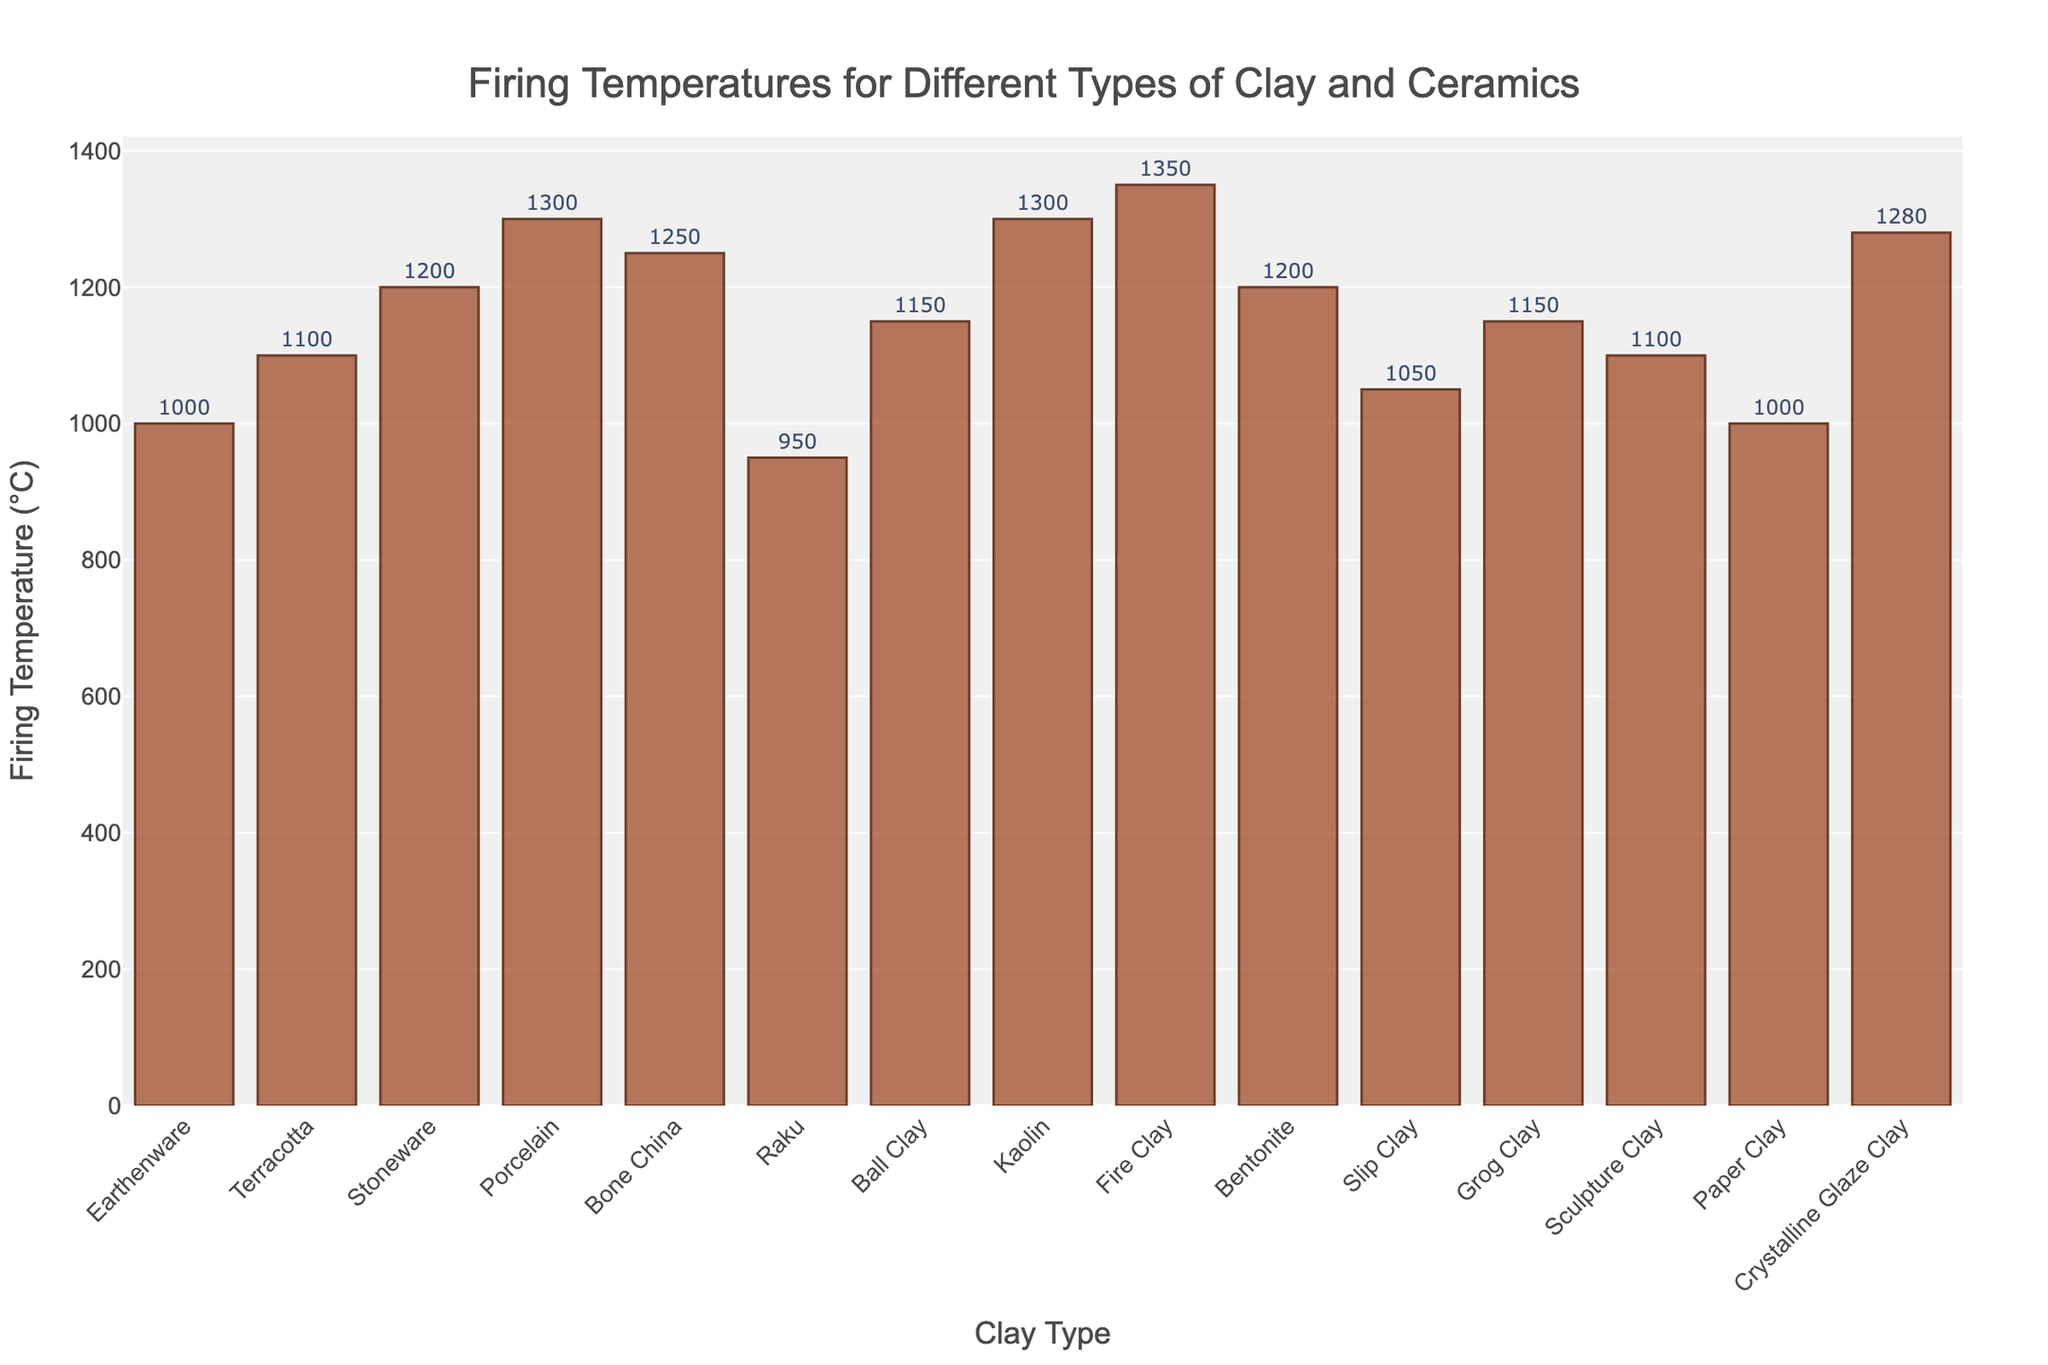Which clay type has the highest firing temperature? The highest bar in the bar chart represents the clay type with the highest firing temperature. Looking at the bars, "Fire Clay" stands out as the highest.
Answer: Fire Clay What is the difference in firing temperature between Porcelain and Earthenware? Find the firing temperatures of Porcelain and Earthenware from the bars and subtract the lower value from the higher. Porcelain is at 1300°C and Earthenware is at 1000°C. So, 1300 - 1000 = 300°C.
Answer: 300°C What is the median firing temperature among all the clay types? List all firing temperatures, sort them in ascending order, and find the middle value. The temperatures are {950, 1000, 1000, 1050, 1100, 1100, 1150, 1150, 1200, 1200, 1250, 1280, 1300, 1300, 1350}. The median is the 8th value which is 1150°C.
Answer: 1150°C Which clay types have firing temperatures less than 1100°C? Identify the bars representing clay types with firing temperatures below 1100°C. These are Earthenware (1000°C), Raku (950°C), Slip Clay (1050°C), and Paper Clay (1000°C).
Answer: Earthenware, Raku, Slip Clay, Paper Clay How many clay types have firing temperatures of 1200°C or higher? Count the bars whose firing temperatures are 1200°C or higher. These clay types are Stoneware (1200°C), Bone China (1250°C), Porcelain (1300°C), Kaolin (1300°C), Fire Clay (1350°C), Bentonite (1200°C), and Crystalline Glaze Clay (1280°C). There are 7 such types.
Answer: 7 What is the average firing temperature of the clay types listed? Sum the firing temperatures and divide by the number of data points. Sum = 950 + 1000 + 1000 + 1050 + 1100 + 1100 + 1150 + 1150 + 1200 + 1200 + 1250 + 1280 + 1300 + 1300 + 1350 = 17330. Number of types = 15. Average = 17330 / 15 ≈ 1155.33°C.
Answer: 1155.33°C Are there any clay types with the same firing temperature? If so, which ones? Look for bars with identical heights. Earthenware (1000°C) and Paper Clay (1000°C) have the same firing temperature. Also, Stoneware (1200°C) and Bentonite (1200°C) have the same firing temperature, as well as Sculpture Clay (1100°C) and Terracotta (1100°C), and Porcelain (1300°C) and Kaolin (1300°C).
Answer: Earthenware and Paper Clay, Stoneware and Bentonite, Sculpture Clay and Terracotta, Porcelain and Kaolin 